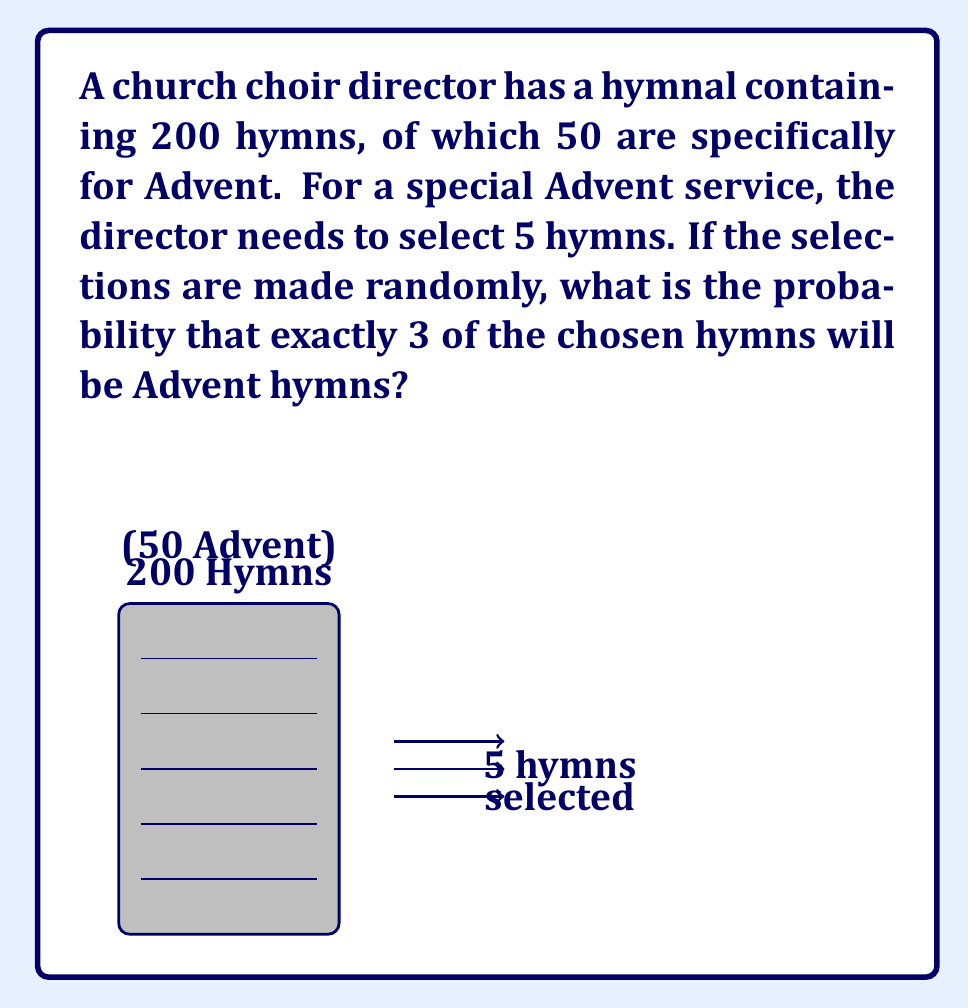Solve this math problem. Let's approach this step-by-step using the hypergeometric distribution:

1) We can think of this as selecting 5 hymns from a total of 200, where we want exactly 3 out of the 50 Advent hymns.

2) The probability of this can be calculated using the hypergeometric distribution formula:

   $$P(X=k) = \frac{\binom{K}{k} \binom{N-K}{n-k}}{\binom{N}{n}}$$

   Where:
   $N$ = total number of hymns = 200
   $K$ = number of Advent hymns = 50
   $n$ = number of hymns selected = 5
   $k$ = number of Advent hymns we want = 3

3) Plugging in these values:

   $$P(X=3) = \frac{\binom{50}{3} \binom{200-50}{5-3}}{\binom{200}{5}}$$

4) Let's calculate each part:
   
   $\binom{50}{3} = 19,600$
   $\binom{150}{2} = 11,175$
   $\binom{200}{5} = 2,535,650,800$

5) Now, let's put it all together:

   $$P(X=3) = \frac{19,600 \times 11,175}{2,535,650,800} = \frac{219,030,000}{2,535,650,800}$$

6) Simplifying:

   $$P(X=3) = \frac{21903}{253565} \approx 0.0864$$
Answer: $\frac{21903}{253565} \approx 0.0864$ or about 8.64% 